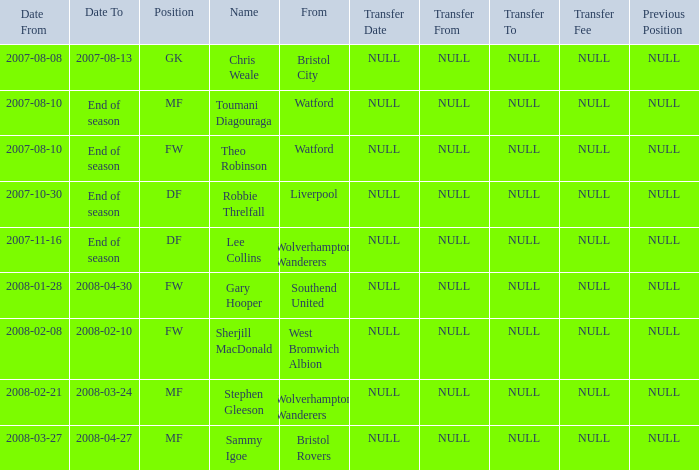What date did Toumani Diagouraga, who played position MF, start? 2007-08-10. 